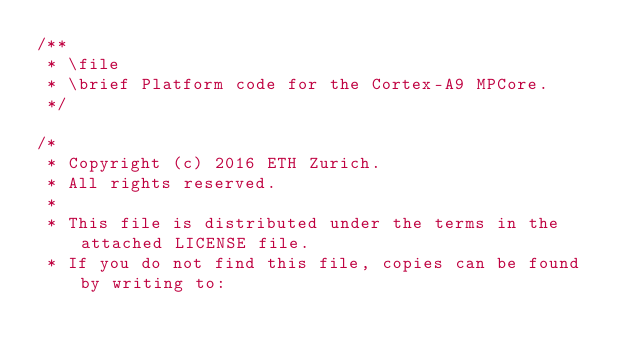<code> <loc_0><loc_0><loc_500><loc_500><_C_>/**
 * \file
 * \brief Platform code for the Cortex-A9 MPCore.
 */

/*
 * Copyright (c) 2016 ETH Zurich.
 * All rights reserved.
 *
 * This file is distributed under the terms in the attached LICENSE file.
 * If you do not find this file, copies can be found by writing to:</code> 